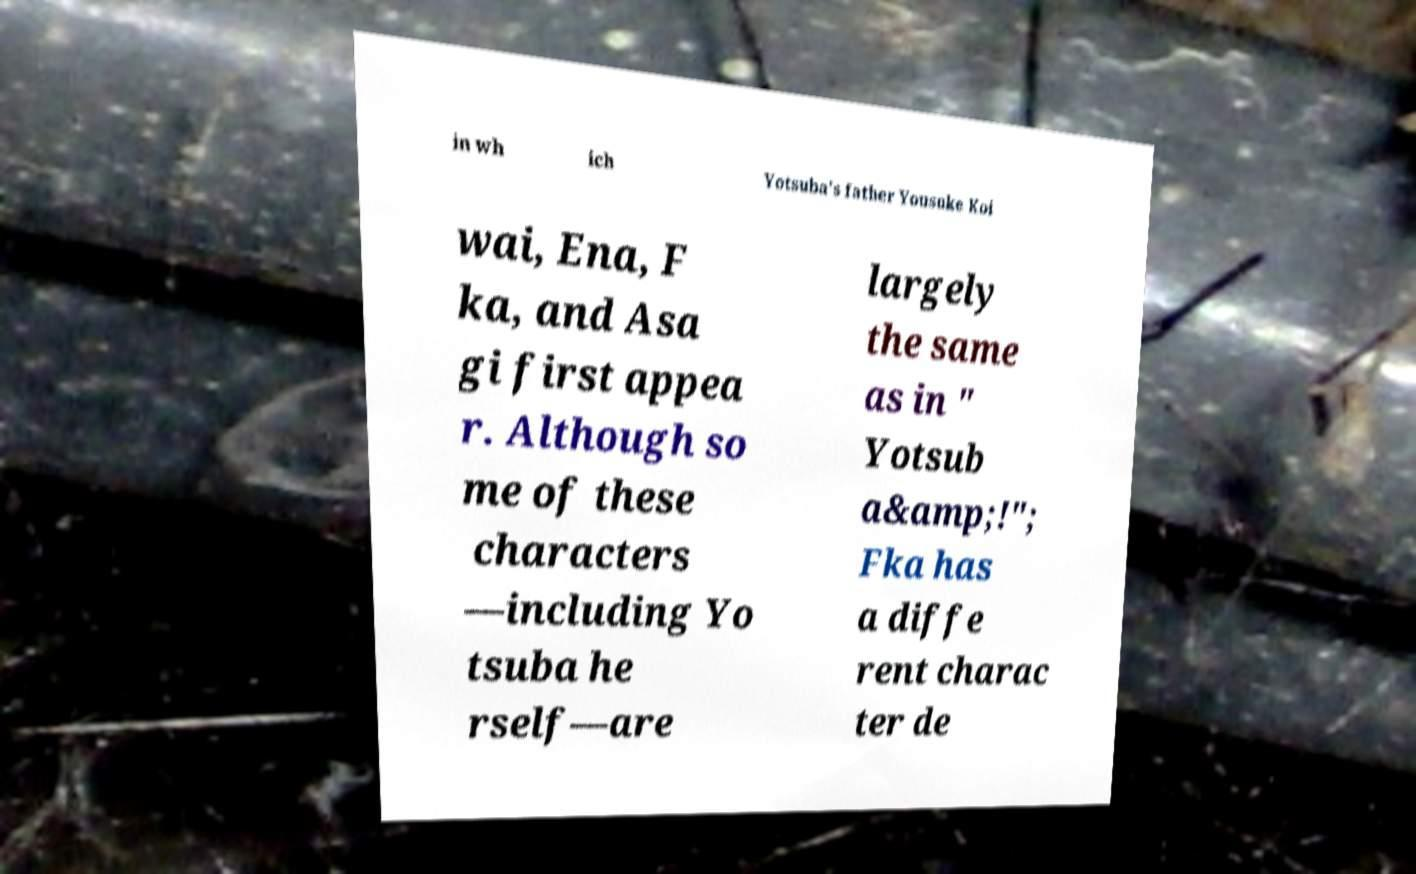I need the written content from this picture converted into text. Can you do that? in wh ich Yotsuba's father Yousuke Koi wai, Ena, F ka, and Asa gi first appea r. Although so me of these characters —including Yo tsuba he rself—are largely the same as in " Yotsub a&amp;!"; Fka has a diffe rent charac ter de 